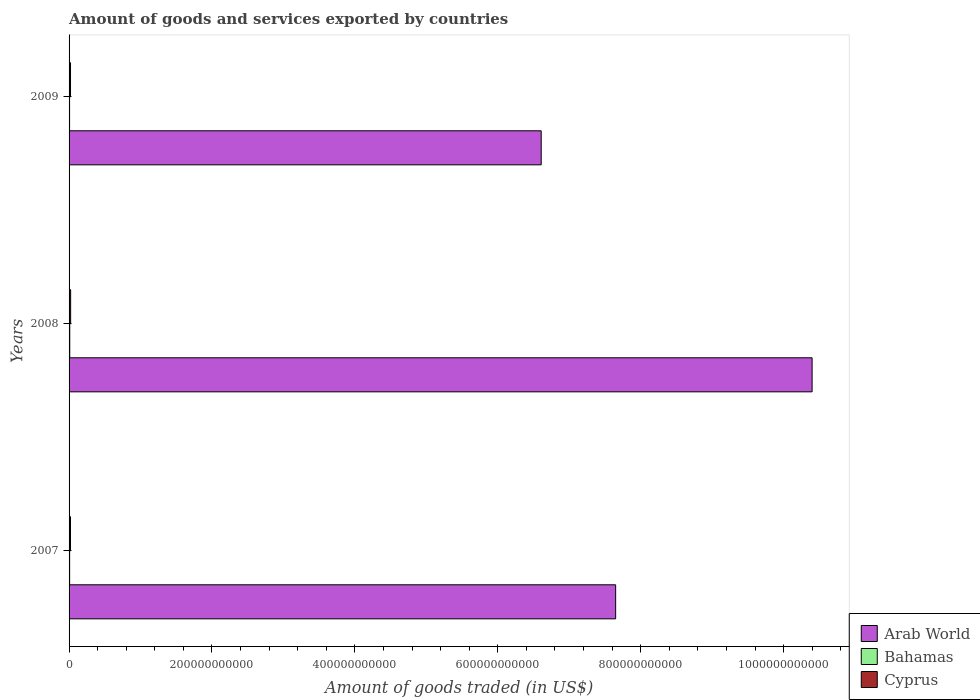How many groups of bars are there?
Provide a succinct answer. 3. Are the number of bars per tick equal to the number of legend labels?
Offer a very short reply. Yes. How many bars are there on the 1st tick from the top?
Keep it short and to the point. 3. In how many cases, is the number of bars for a given year not equal to the number of legend labels?
Your answer should be compact. 0. What is the total amount of goods and services exported in Cyprus in 2007?
Make the answer very short. 1.99e+09. Across all years, what is the maximum total amount of goods and services exported in Bahamas?
Give a very brief answer. 9.56e+08. Across all years, what is the minimum total amount of goods and services exported in Cyprus?
Ensure brevity in your answer.  1.99e+09. In which year was the total amount of goods and services exported in Cyprus minimum?
Provide a succinct answer. 2007. What is the total total amount of goods and services exported in Bahamas in the graph?
Offer a terse response. 2.47e+09. What is the difference between the total amount of goods and services exported in Arab World in 2007 and that in 2009?
Provide a succinct answer. 1.04e+11. What is the difference between the total amount of goods and services exported in Arab World in 2009 and the total amount of goods and services exported in Cyprus in 2007?
Offer a very short reply. 6.59e+11. What is the average total amount of goods and services exported in Cyprus per year?
Offer a very short reply. 2.07e+09. In the year 2008, what is the difference between the total amount of goods and services exported in Arab World and total amount of goods and services exported in Bahamas?
Provide a short and direct response. 1.04e+12. What is the ratio of the total amount of goods and services exported in Arab World in 2008 to that in 2009?
Make the answer very short. 1.57. What is the difference between the highest and the second highest total amount of goods and services exported in Cyprus?
Provide a short and direct response. 1.82e+08. What is the difference between the highest and the lowest total amount of goods and services exported in Cyprus?
Your answer should be very brief. 2.20e+08. In how many years, is the total amount of goods and services exported in Arab World greater than the average total amount of goods and services exported in Arab World taken over all years?
Your answer should be compact. 1. Is the sum of the total amount of goods and services exported in Cyprus in 2007 and 2009 greater than the maximum total amount of goods and services exported in Arab World across all years?
Provide a succinct answer. No. What does the 1st bar from the top in 2007 represents?
Offer a very short reply. Cyprus. What does the 2nd bar from the bottom in 2007 represents?
Provide a short and direct response. Bahamas. Is it the case that in every year, the sum of the total amount of goods and services exported in Cyprus and total amount of goods and services exported in Bahamas is greater than the total amount of goods and services exported in Arab World?
Your answer should be compact. No. How many bars are there?
Provide a short and direct response. 9. What is the difference between two consecutive major ticks on the X-axis?
Your answer should be compact. 2.00e+11. Does the graph contain any zero values?
Provide a short and direct response. No. Does the graph contain grids?
Your response must be concise. No. Where does the legend appear in the graph?
Give a very brief answer. Bottom right. What is the title of the graph?
Provide a short and direct response. Amount of goods and services exported by countries. Does "Iraq" appear as one of the legend labels in the graph?
Offer a very short reply. No. What is the label or title of the X-axis?
Offer a terse response. Amount of goods traded (in US$). What is the Amount of goods traded (in US$) of Arab World in 2007?
Provide a short and direct response. 7.65e+11. What is the Amount of goods traded (in US$) of Bahamas in 2007?
Make the answer very short. 8.02e+08. What is the Amount of goods traded (in US$) of Cyprus in 2007?
Your answer should be compact. 1.99e+09. What is the Amount of goods traded (in US$) in Arab World in 2008?
Keep it short and to the point. 1.04e+12. What is the Amount of goods traded (in US$) in Bahamas in 2008?
Keep it short and to the point. 9.56e+08. What is the Amount of goods traded (in US$) in Cyprus in 2008?
Your response must be concise. 2.21e+09. What is the Amount of goods traded (in US$) of Arab World in 2009?
Give a very brief answer. 6.61e+11. What is the Amount of goods traded (in US$) in Bahamas in 2009?
Your answer should be compact. 7.11e+08. What is the Amount of goods traded (in US$) in Cyprus in 2009?
Provide a short and direct response. 2.02e+09. Across all years, what is the maximum Amount of goods traded (in US$) in Arab World?
Offer a very short reply. 1.04e+12. Across all years, what is the maximum Amount of goods traded (in US$) in Bahamas?
Your response must be concise. 9.56e+08. Across all years, what is the maximum Amount of goods traded (in US$) in Cyprus?
Provide a short and direct response. 2.21e+09. Across all years, what is the minimum Amount of goods traded (in US$) in Arab World?
Your answer should be very brief. 6.61e+11. Across all years, what is the minimum Amount of goods traded (in US$) in Bahamas?
Offer a very short reply. 7.11e+08. Across all years, what is the minimum Amount of goods traded (in US$) in Cyprus?
Provide a short and direct response. 1.99e+09. What is the total Amount of goods traded (in US$) in Arab World in the graph?
Give a very brief answer. 2.47e+12. What is the total Amount of goods traded (in US$) of Bahamas in the graph?
Offer a terse response. 2.47e+09. What is the total Amount of goods traded (in US$) of Cyprus in the graph?
Offer a terse response. 6.22e+09. What is the difference between the Amount of goods traded (in US$) in Arab World in 2007 and that in 2008?
Ensure brevity in your answer.  -2.75e+11. What is the difference between the Amount of goods traded (in US$) of Bahamas in 2007 and that in 2008?
Your answer should be very brief. -1.54e+08. What is the difference between the Amount of goods traded (in US$) in Cyprus in 2007 and that in 2008?
Your response must be concise. -2.20e+08. What is the difference between the Amount of goods traded (in US$) in Arab World in 2007 and that in 2009?
Offer a very short reply. 1.04e+11. What is the difference between the Amount of goods traded (in US$) of Bahamas in 2007 and that in 2009?
Offer a terse response. 9.12e+07. What is the difference between the Amount of goods traded (in US$) in Cyprus in 2007 and that in 2009?
Provide a short and direct response. -3.84e+07. What is the difference between the Amount of goods traded (in US$) in Arab World in 2008 and that in 2009?
Offer a very short reply. 3.79e+11. What is the difference between the Amount of goods traded (in US$) in Bahamas in 2008 and that in 2009?
Ensure brevity in your answer.  2.45e+08. What is the difference between the Amount of goods traded (in US$) in Cyprus in 2008 and that in 2009?
Ensure brevity in your answer.  1.82e+08. What is the difference between the Amount of goods traded (in US$) in Arab World in 2007 and the Amount of goods traded (in US$) in Bahamas in 2008?
Provide a short and direct response. 7.64e+11. What is the difference between the Amount of goods traded (in US$) of Arab World in 2007 and the Amount of goods traded (in US$) of Cyprus in 2008?
Keep it short and to the point. 7.63e+11. What is the difference between the Amount of goods traded (in US$) of Bahamas in 2007 and the Amount of goods traded (in US$) of Cyprus in 2008?
Provide a short and direct response. -1.40e+09. What is the difference between the Amount of goods traded (in US$) in Arab World in 2007 and the Amount of goods traded (in US$) in Bahamas in 2009?
Your answer should be compact. 7.64e+11. What is the difference between the Amount of goods traded (in US$) in Arab World in 2007 and the Amount of goods traded (in US$) in Cyprus in 2009?
Your answer should be compact. 7.63e+11. What is the difference between the Amount of goods traded (in US$) in Bahamas in 2007 and the Amount of goods traded (in US$) in Cyprus in 2009?
Provide a short and direct response. -1.22e+09. What is the difference between the Amount of goods traded (in US$) in Arab World in 2008 and the Amount of goods traded (in US$) in Bahamas in 2009?
Provide a succinct answer. 1.04e+12. What is the difference between the Amount of goods traded (in US$) of Arab World in 2008 and the Amount of goods traded (in US$) of Cyprus in 2009?
Your answer should be very brief. 1.04e+12. What is the difference between the Amount of goods traded (in US$) in Bahamas in 2008 and the Amount of goods traded (in US$) in Cyprus in 2009?
Offer a very short reply. -1.07e+09. What is the average Amount of goods traded (in US$) of Arab World per year?
Offer a terse response. 8.22e+11. What is the average Amount of goods traded (in US$) in Bahamas per year?
Ensure brevity in your answer.  8.23e+08. What is the average Amount of goods traded (in US$) of Cyprus per year?
Make the answer very short. 2.07e+09. In the year 2007, what is the difference between the Amount of goods traded (in US$) in Arab World and Amount of goods traded (in US$) in Bahamas?
Your answer should be very brief. 7.64e+11. In the year 2007, what is the difference between the Amount of goods traded (in US$) of Arab World and Amount of goods traded (in US$) of Cyprus?
Provide a short and direct response. 7.63e+11. In the year 2007, what is the difference between the Amount of goods traded (in US$) in Bahamas and Amount of goods traded (in US$) in Cyprus?
Your answer should be compact. -1.18e+09. In the year 2008, what is the difference between the Amount of goods traded (in US$) in Arab World and Amount of goods traded (in US$) in Bahamas?
Give a very brief answer. 1.04e+12. In the year 2008, what is the difference between the Amount of goods traded (in US$) of Arab World and Amount of goods traded (in US$) of Cyprus?
Your answer should be very brief. 1.04e+12. In the year 2008, what is the difference between the Amount of goods traded (in US$) of Bahamas and Amount of goods traded (in US$) of Cyprus?
Provide a short and direct response. -1.25e+09. In the year 2009, what is the difference between the Amount of goods traded (in US$) of Arab World and Amount of goods traded (in US$) of Bahamas?
Offer a terse response. 6.60e+11. In the year 2009, what is the difference between the Amount of goods traded (in US$) of Arab World and Amount of goods traded (in US$) of Cyprus?
Provide a succinct answer. 6.59e+11. In the year 2009, what is the difference between the Amount of goods traded (in US$) of Bahamas and Amount of goods traded (in US$) of Cyprus?
Offer a terse response. -1.31e+09. What is the ratio of the Amount of goods traded (in US$) of Arab World in 2007 to that in 2008?
Make the answer very short. 0.74. What is the ratio of the Amount of goods traded (in US$) in Bahamas in 2007 to that in 2008?
Offer a terse response. 0.84. What is the ratio of the Amount of goods traded (in US$) in Cyprus in 2007 to that in 2008?
Give a very brief answer. 0.9. What is the ratio of the Amount of goods traded (in US$) in Arab World in 2007 to that in 2009?
Give a very brief answer. 1.16. What is the ratio of the Amount of goods traded (in US$) in Bahamas in 2007 to that in 2009?
Your answer should be compact. 1.13. What is the ratio of the Amount of goods traded (in US$) of Cyprus in 2007 to that in 2009?
Provide a short and direct response. 0.98. What is the ratio of the Amount of goods traded (in US$) of Arab World in 2008 to that in 2009?
Offer a very short reply. 1.57. What is the ratio of the Amount of goods traded (in US$) of Bahamas in 2008 to that in 2009?
Offer a terse response. 1.34. What is the ratio of the Amount of goods traded (in US$) in Cyprus in 2008 to that in 2009?
Ensure brevity in your answer.  1.09. What is the difference between the highest and the second highest Amount of goods traded (in US$) of Arab World?
Keep it short and to the point. 2.75e+11. What is the difference between the highest and the second highest Amount of goods traded (in US$) of Bahamas?
Make the answer very short. 1.54e+08. What is the difference between the highest and the second highest Amount of goods traded (in US$) of Cyprus?
Keep it short and to the point. 1.82e+08. What is the difference between the highest and the lowest Amount of goods traded (in US$) of Arab World?
Your answer should be very brief. 3.79e+11. What is the difference between the highest and the lowest Amount of goods traded (in US$) of Bahamas?
Provide a short and direct response. 2.45e+08. What is the difference between the highest and the lowest Amount of goods traded (in US$) of Cyprus?
Keep it short and to the point. 2.20e+08. 